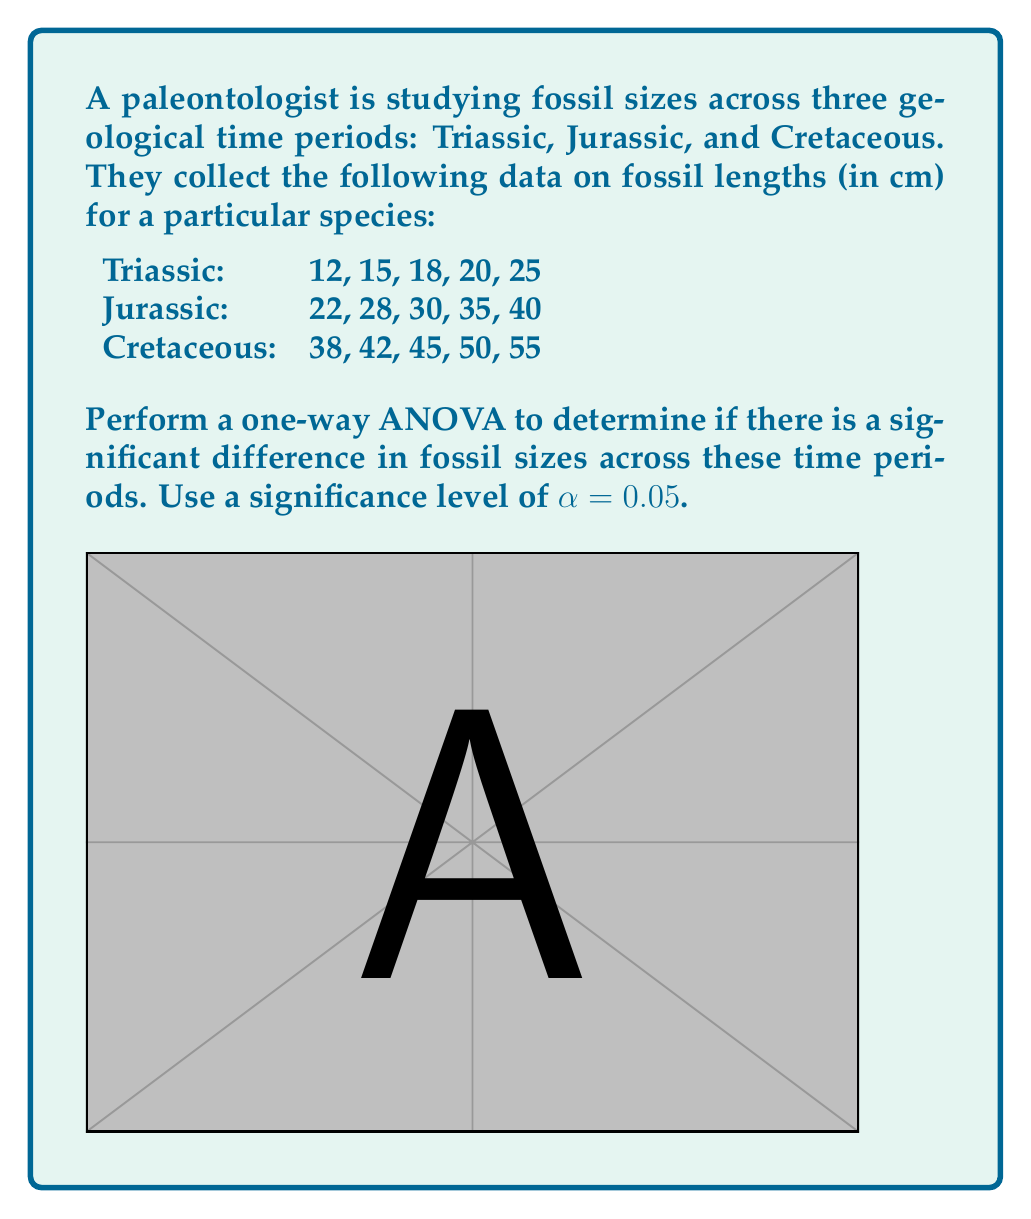Help me with this question. To perform a one-way ANOVA, we'll follow these steps:

1) Calculate the sum of squares:

   a) Total Sum of Squares (SST):
      $$SST = \sum_{i=1}^{n} (x_i - \bar{x})^2$$
      where $x_i$ are all individual measurements and $\bar{x}$ is the grand mean.

   b) Between-group Sum of Squares (SSB):
      $$SSB = \sum_{j=1}^{k} n_j(\bar{x}_j - \bar{x})^2$$
      where $k$ is the number of groups, $n_j$ is the size of each group, and $\bar{x}_j$ is the mean of each group.

   c) Within-group Sum of Squares (SSW):
      $$SSW = SST - SSB$$

2) Calculate degrees of freedom:
   - Total df: $n - 1 = 15 - 1 = 14$
   - Between-group df: $k - 1 = 3 - 1 = 2$
   - Within-group df: $n - k = 15 - 3 = 12$

3) Calculate Mean Squares:
   $$MSB = \frac{SSB}{df_B}, MSW = \frac{SSW}{df_W}$$

4) Calculate F-statistic:
   $$F = \frac{MSB}{MSW}$$

5) Compare F-statistic to critical F-value:
   $F_{crit} = F_{0.05, 2, 12}$ (from F-distribution table)

Calculations:
Grand mean $\bar{x} = 31.67$

SST = 3466.67
SSB = 3120.00
SSW = 346.67

MSB = 1560.00
MSW = 28.89

F = 54.00

$F_{crit} = 3.89$ (from F-distribution table)

Since $F > F_{crit}$, we reject the null hypothesis.
Answer: Reject null hypothesis; significant difference in fossil sizes across time periods (F = 54.00, p < 0.05). 